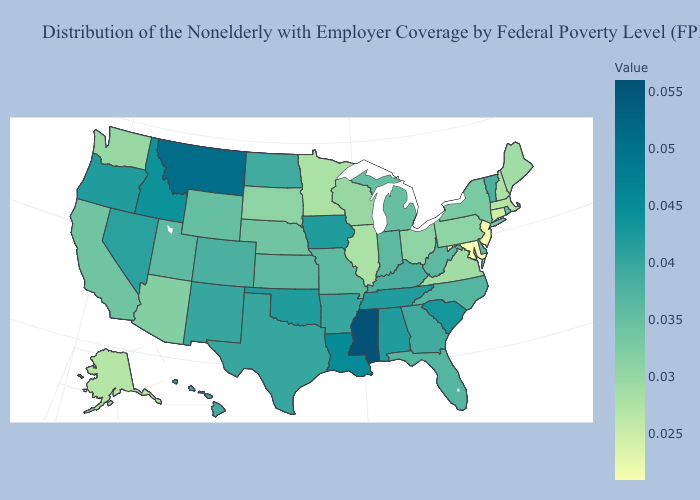Is the legend a continuous bar?
Write a very short answer. Yes. Among the states that border Nebraska , which have the lowest value?
Short answer required. South Dakota. Does Kansas have the lowest value in the MidWest?
Give a very brief answer. No. Among the states that border New Hampshire , which have the lowest value?
Short answer required. Massachusetts. Among the states that border New Hampshire , does Maine have the lowest value?
Be succinct. No. 